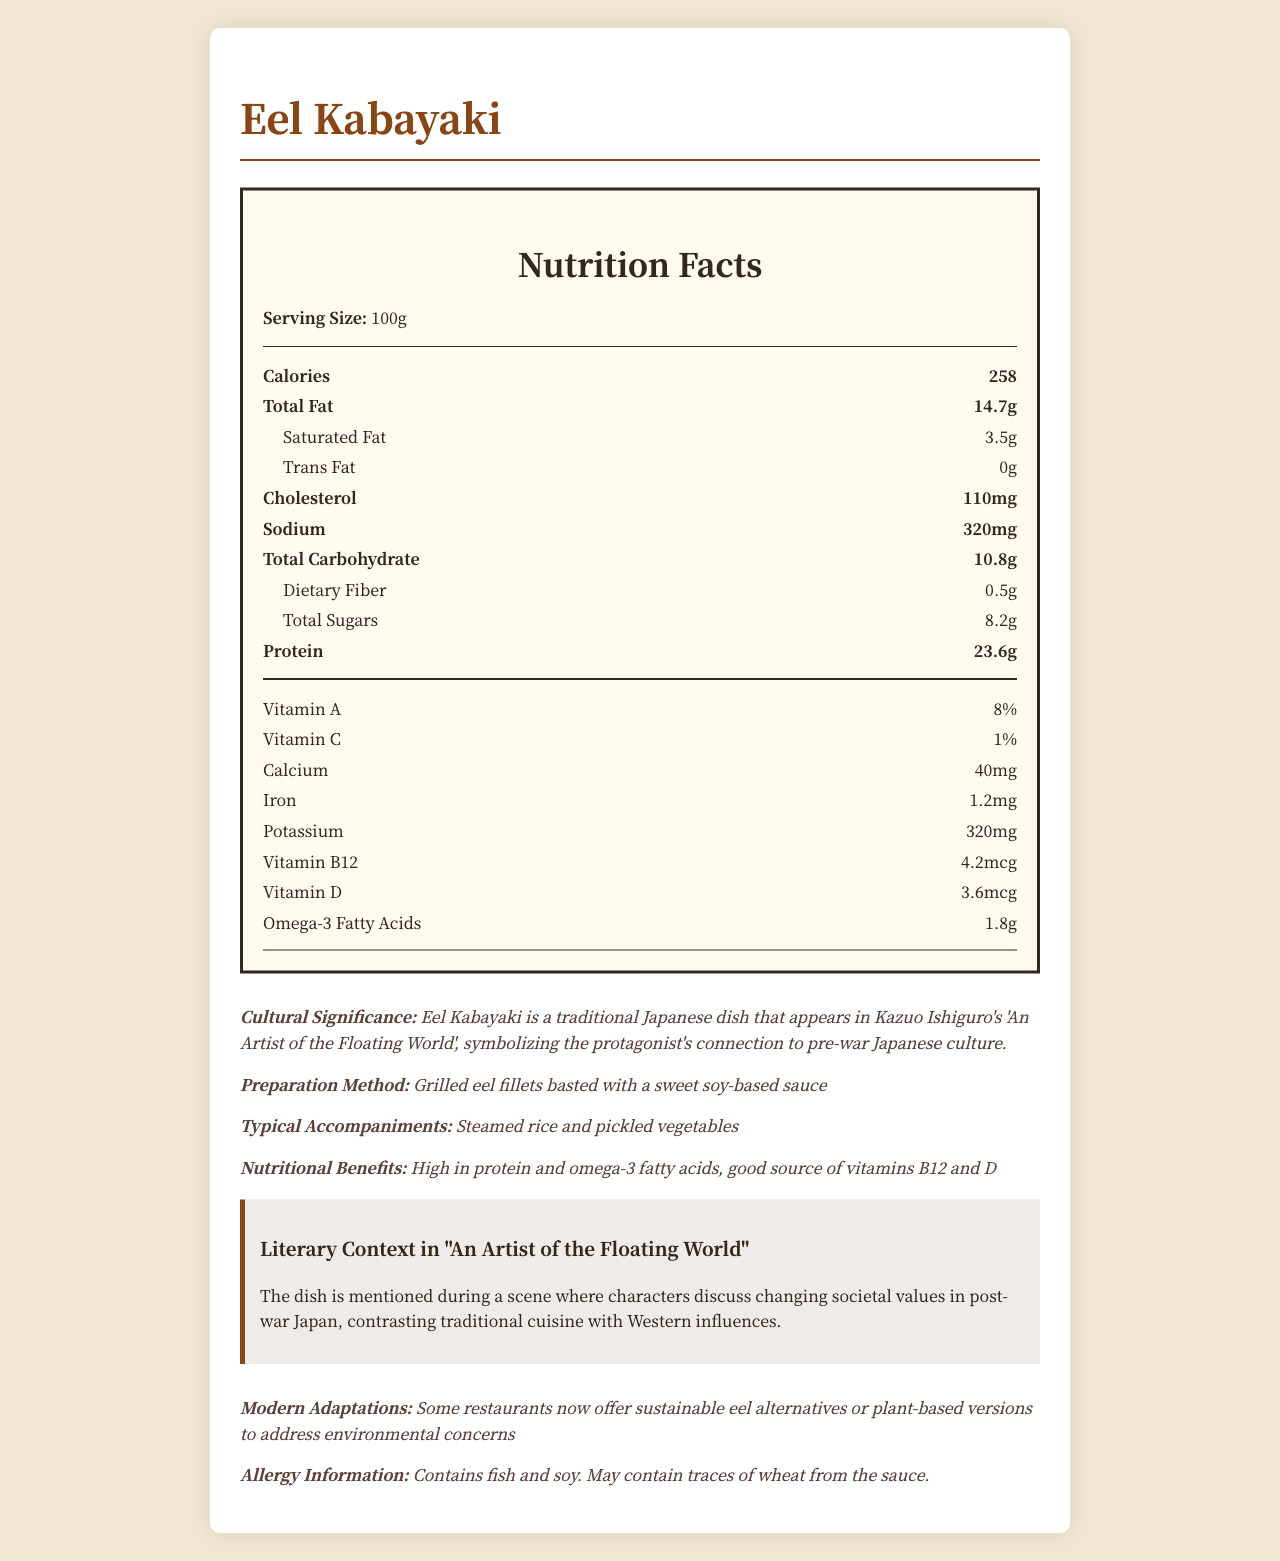what is the serving size for Eel Kabayaki? The serving size is explicitly mentioned as "100g" in the Nutrition Facts section of the document.
Answer: 100g How many calories are there per serving? The document states that there are 258 calories per 100g serving.
Answer: 258 What are the total carbohydrates in Eel Kabayaki? The total carbohydrate content is listed as 10.8g in the Nutrition Facts section.
Answer: 10.8g How much protein does Eel Kabayaki contain per serving? The document specifies that the protein content per serving is 23.6g.
Answer: 23.6g What is the cultural significance of Eel Kabayaki in Ishiguro's "An Artist of the Floating World"? The document mentions that Eel Kabayaki is a traditional Japanese dish symbolizing the main character's link to pre-war Japanese traditions.
Answer: Eel Kabayaki symbolizes the protagonist's connection to pre-war Japanese culture. What is the cholesterol content of Eel Kabayaki? A. 90mg B. 110mg C. 150mg The cholesterol content is listed as 110mg per serving in the Nutrition Facts section.
Answer: B Which of the following vitamins are contained in Eel Kabayaki? I. Vitamin A II. Vitamin B12 III. Vitamin K The document states that Eel Kabayaki contains Vitamin A and Vitamin B12 among the nutrients listed, but does not mention Vitamin K.
Answer: I and II Is Eel Kabayaki high in protein? The protein content per serving is 23.6g, which is high relative to other nutritional components.
Answer: Yes Summarize the nutritional content of Eel Kabayaki and its significance in Ishiguro's literature. The document provides a detailed breakdown of the nutritional content including macronutrients and vitamins, along with the cultural and literary contexts in which the dish appears in Ishiguro's work.
Answer: Eel Kabayaki is a traditional Japanese dish with a serving size of 100g, containing 258 calories, 14.7g of total fat, 23.6g of protein, and moderate amounts of vitamins and minerals like Vitamin A, Vitamin B12, calcium, and iron. It is culturally significant in Ishiguro's "An Artist of the Floating World," representing the protagonist's connection to pre-war Japanese culture, and is also discussed in the context of changing societal values in post-war Japan. What are the typical accompaniments served with Eel Kabayaki? The document lists steamed rice and pickled vegetables as typical accompaniments.
Answer: Steamed rice and pickled vegetables Can the dish be considered environmentally friendly based on the traditional preparation method? While the document mentions modern adaptations for sustainability, it doesn't provide enough information about the environmental impact of the traditional preparation method of Eel Kabayaki.
Answer: Not enough information 